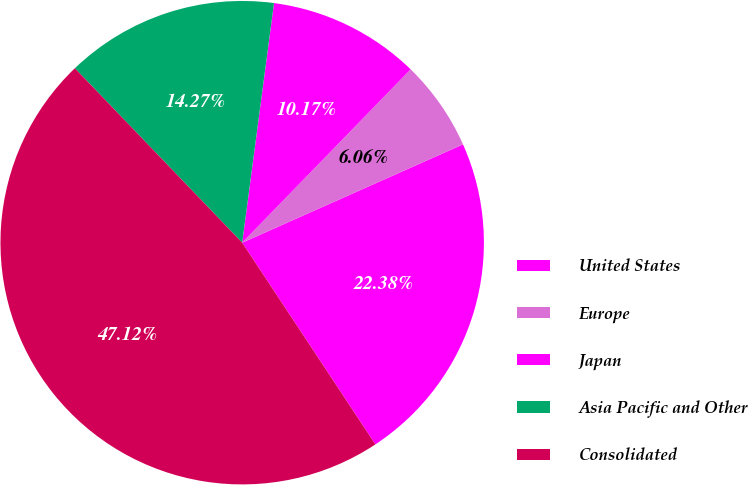Convert chart. <chart><loc_0><loc_0><loc_500><loc_500><pie_chart><fcel>United States<fcel>Europe<fcel>Japan<fcel>Asia Pacific and Other<fcel>Consolidated<nl><fcel>22.38%<fcel>6.06%<fcel>10.17%<fcel>14.27%<fcel>47.12%<nl></chart> 